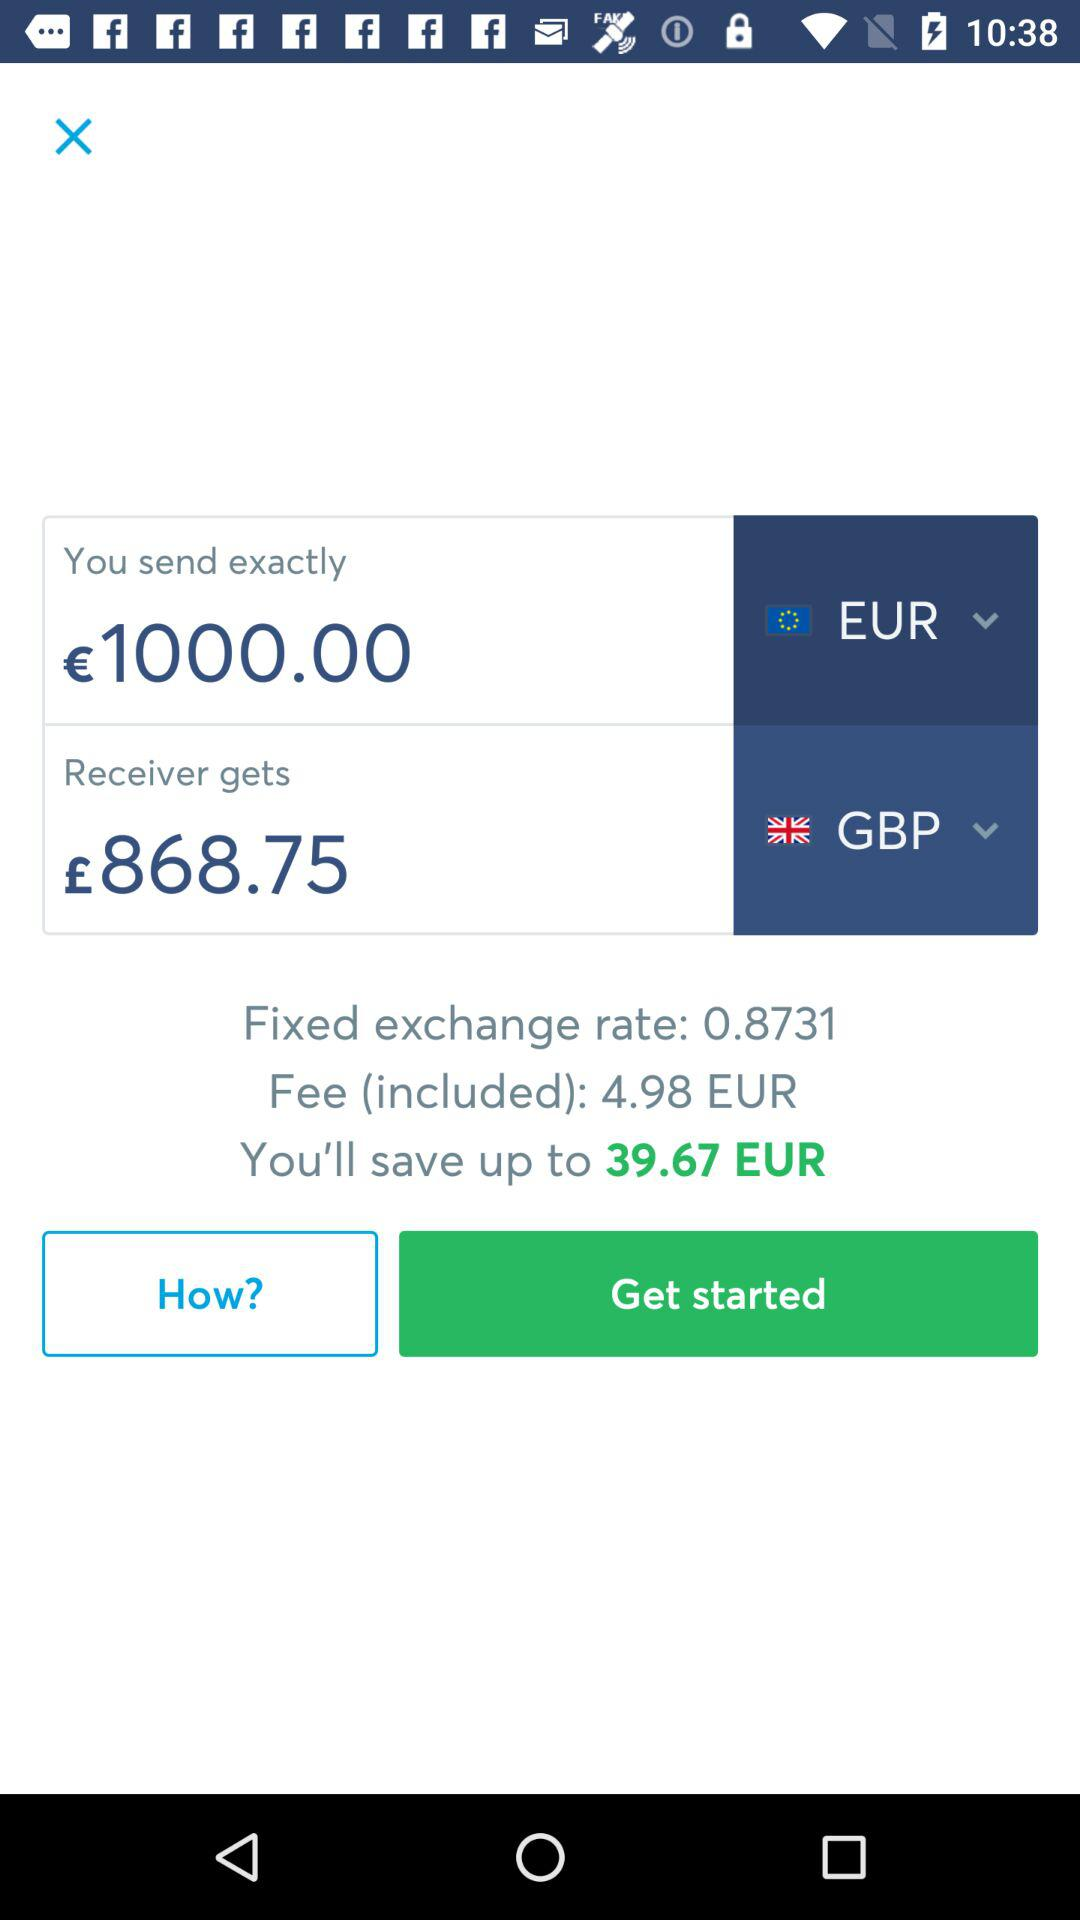How much money did I send exactly? You sent €1000 exactly. 